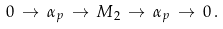Convert formula to latex. <formula><loc_0><loc_0><loc_500><loc_500>0 \, \to \, \alpha _ { p } \, \to \, M _ { 2 } \, \to \, \alpha _ { p } \, \to \, 0 \, .</formula> 